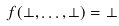<formula> <loc_0><loc_0><loc_500><loc_500>f ( \bot , \dots , \bot ) = \bot</formula> 